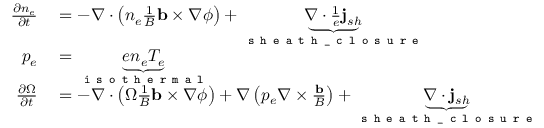Convert formula to latex. <formula><loc_0><loc_0><loc_500><loc_500>\begin{array} { r l } { \frac { \partial n _ { e } } { \partial t } } & = - \nabla \cdot \left ( n _ { e } \frac { 1 } { B } b \times \nabla \phi \right ) + \underbrace { \nabla \cdot { \frac { 1 } { e } j _ { s h } } } _ { s h e a t h \_ c l o s u r e } } \\ { p _ { e } } & = \underbrace { e n _ { e } T _ { e } } _ { i s o t h e r m a l } } \\ { \frac { \partial \Omega } { \partial t } } & = - \nabla \cdot \left ( \Omega \frac { 1 } { B } b \times \nabla \phi \right ) + \nabla \left ( p _ { e } \nabla \times \frac { b } { B } \right ) + \underbrace { \nabla \cdot j _ { s h } } _ { s h e a t h \_ c l o s u r e } } \end{array}</formula> 